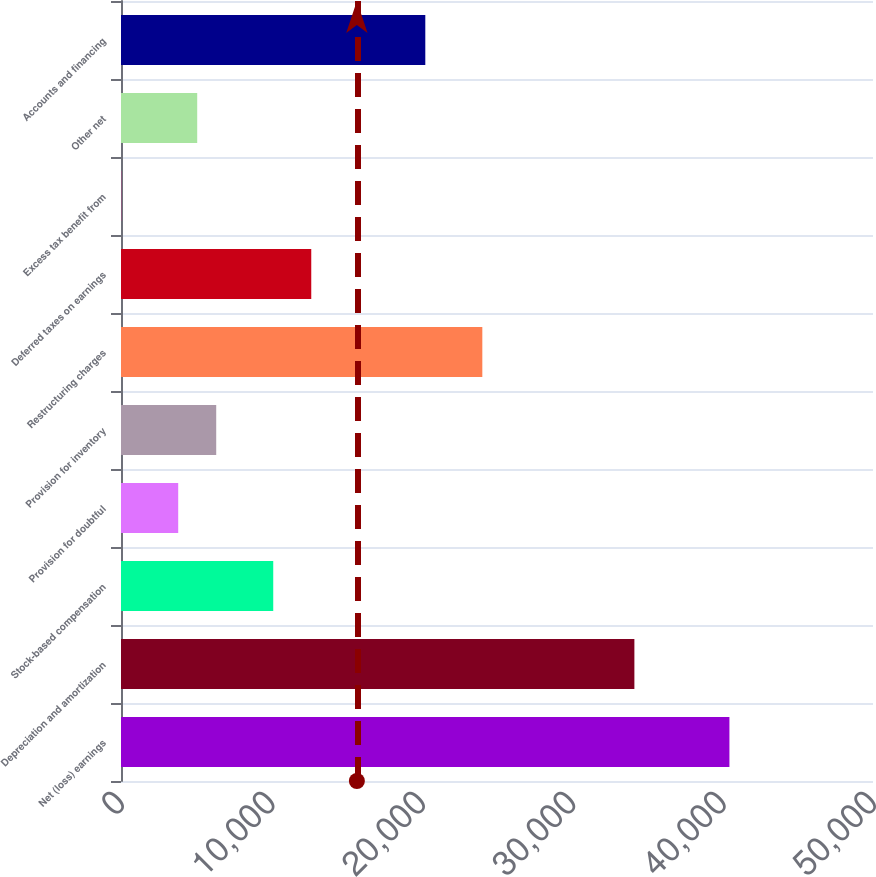Convert chart to OTSL. <chart><loc_0><loc_0><loc_500><loc_500><bar_chart><fcel>Net (loss) earnings<fcel>Depreciation and amortization<fcel>Stock-based compensation<fcel>Provision for doubtful<fcel>Provision for inventory<fcel>Restructuring charges<fcel>Deferred taxes on earnings<fcel>Excess tax benefit from<fcel>Other net<fcel>Accounts and financing<nl><fcel>40453.6<fcel>34134.6<fcel>10122.4<fcel>3803.4<fcel>6331<fcel>24024.2<fcel>12650<fcel>12<fcel>5067.2<fcel>20232.8<nl></chart> 